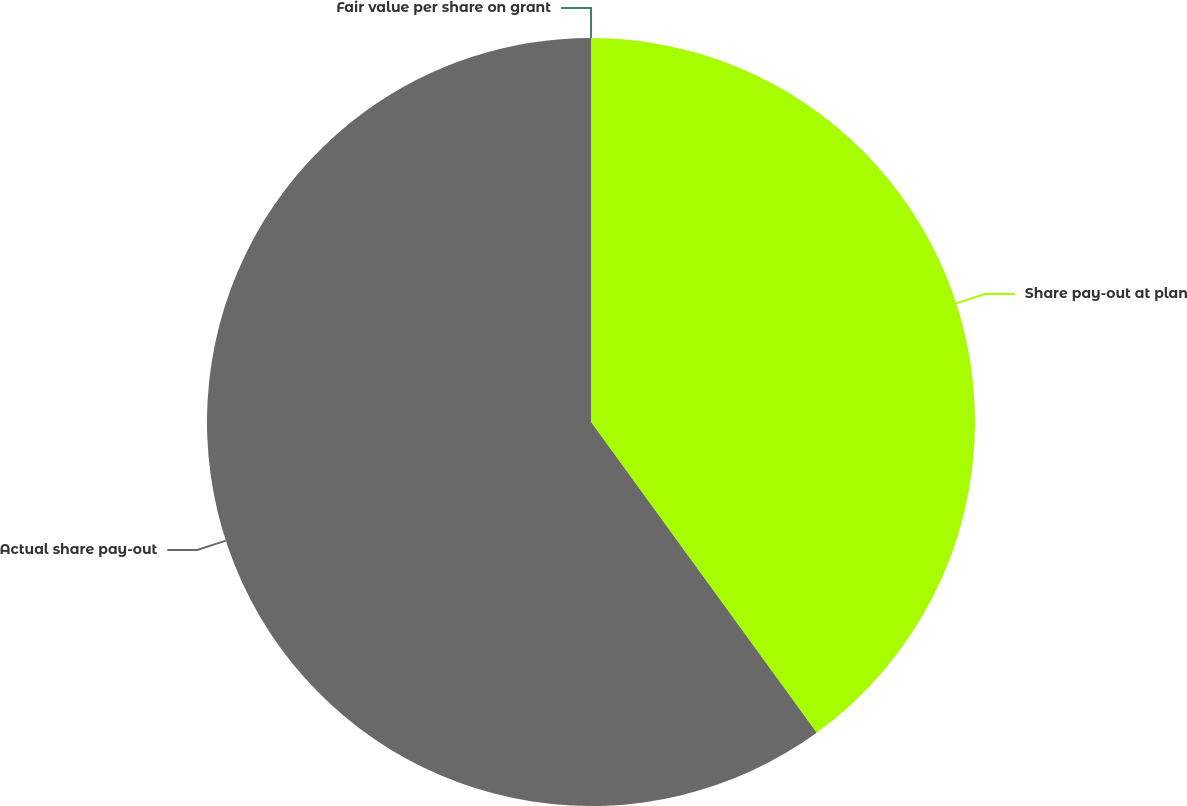Convert chart. <chart><loc_0><loc_0><loc_500><loc_500><pie_chart><fcel>Share pay-out at plan<fcel>Actual share pay-out<fcel>Fair value per share on grant<nl><fcel>40.0%<fcel>60.0%<fcel>0.0%<nl></chart> 